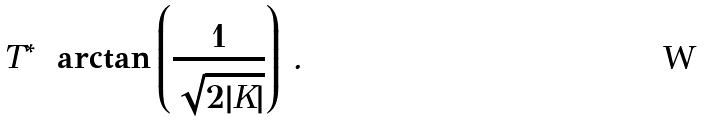Convert formula to latex. <formula><loc_0><loc_0><loc_500><loc_500>T ^ { * } = \arctan \left ( \frac { 1 } { \sqrt { 2 | K | } } \right ) \, .</formula> 